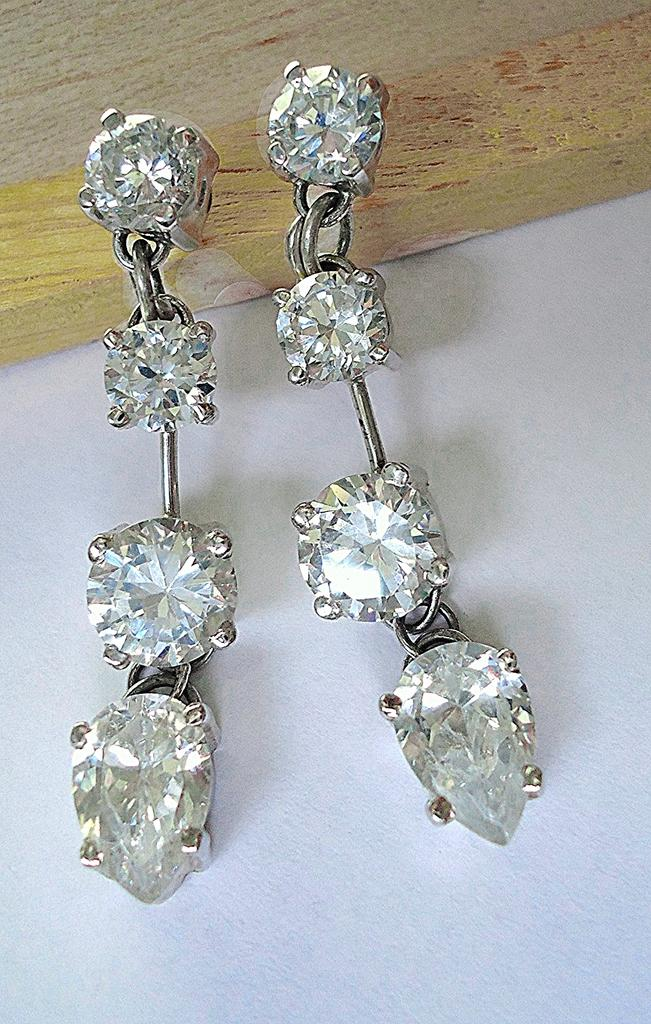What type of jewelry is present in the image? There are earrings in the image. How are the earrings displayed in the image? The earrings are hanged on wood. What color is the background of the image? The background of the image is white. What type of pie is being served in the image? There is no pie present in the image; it features earrings hung on wood with a white background. 